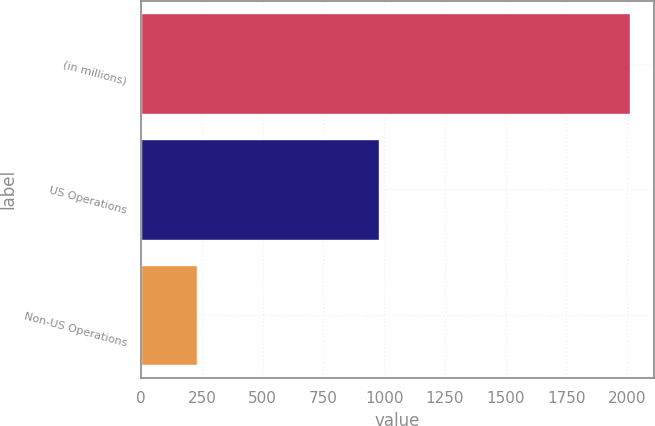Convert chart to OTSL. <chart><loc_0><loc_0><loc_500><loc_500><bar_chart><fcel>(in millions)<fcel>US Operations<fcel>Non-US Operations<nl><fcel>2010<fcel>979.6<fcel>232<nl></chart> 